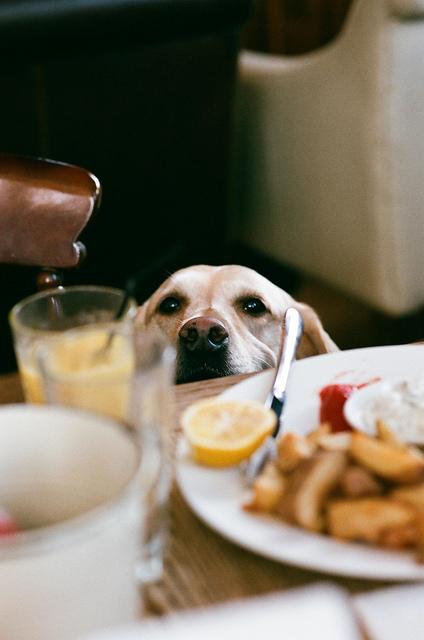How many cups are on the table?
Be succinct. 2. Where is the dog?
Answer briefly. Under table. What animal is near the table?
Be succinct. Dog. 